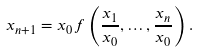Convert formula to latex. <formula><loc_0><loc_0><loc_500><loc_500>x _ { n + 1 } = x _ { 0 } f \left ( \frac { x _ { 1 } } { x _ { 0 } } , \dots , \frac { x _ { n } } { x _ { 0 } } \right ) .</formula> 